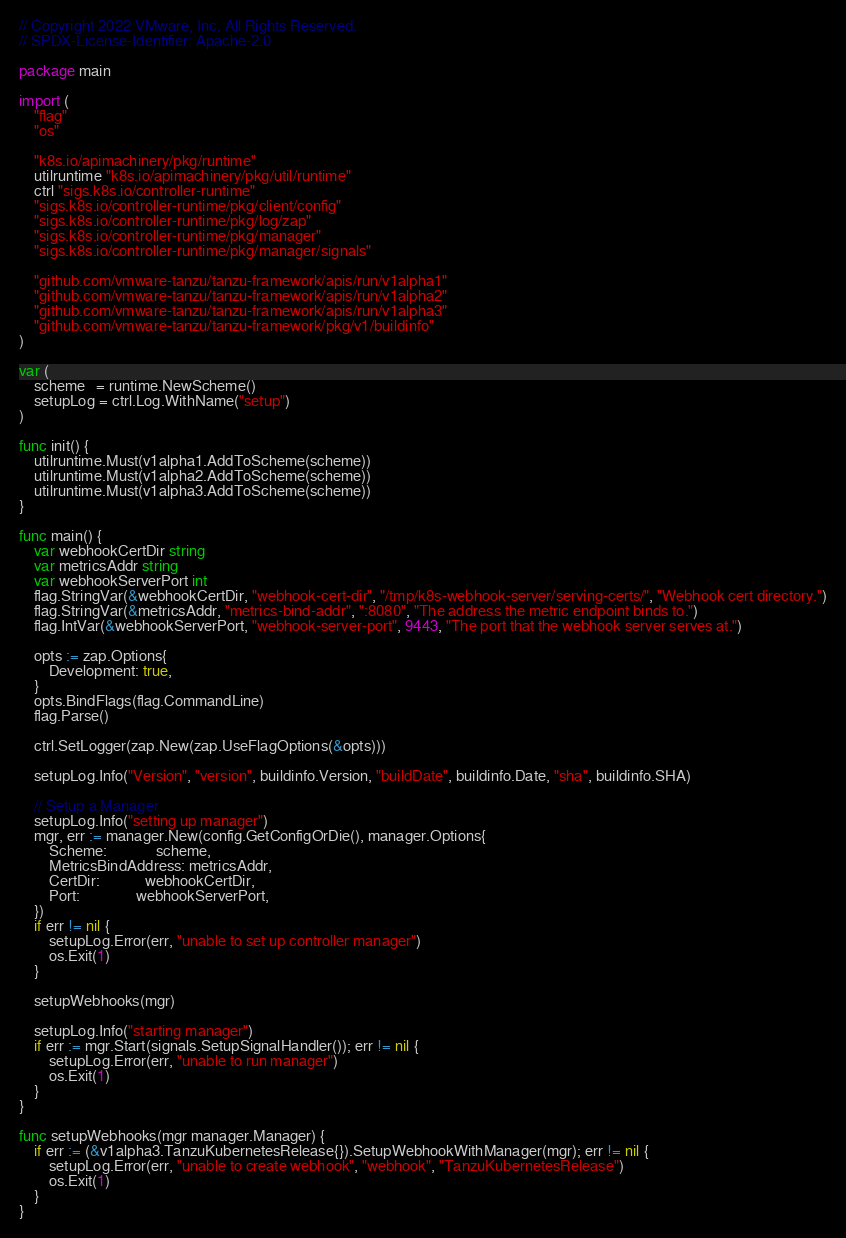Convert code to text. <code><loc_0><loc_0><loc_500><loc_500><_Go_>// Copyright 2022 VMware, Inc. All Rights Reserved.
// SPDX-License-Identifier: Apache-2.0

package main

import (
	"flag"
	"os"

	"k8s.io/apimachinery/pkg/runtime"
	utilruntime "k8s.io/apimachinery/pkg/util/runtime"
	ctrl "sigs.k8s.io/controller-runtime"
	"sigs.k8s.io/controller-runtime/pkg/client/config"
	"sigs.k8s.io/controller-runtime/pkg/log/zap"
	"sigs.k8s.io/controller-runtime/pkg/manager"
	"sigs.k8s.io/controller-runtime/pkg/manager/signals"

	"github.com/vmware-tanzu/tanzu-framework/apis/run/v1alpha1"
	"github.com/vmware-tanzu/tanzu-framework/apis/run/v1alpha2"
	"github.com/vmware-tanzu/tanzu-framework/apis/run/v1alpha3"
	"github.com/vmware-tanzu/tanzu-framework/pkg/v1/buildinfo"
)

var (
	scheme   = runtime.NewScheme()
	setupLog = ctrl.Log.WithName("setup")
)

func init() {
	utilruntime.Must(v1alpha1.AddToScheme(scheme))
	utilruntime.Must(v1alpha2.AddToScheme(scheme))
	utilruntime.Must(v1alpha3.AddToScheme(scheme))
}

func main() {
	var webhookCertDir string
	var metricsAddr string
	var webhookServerPort int
	flag.StringVar(&webhookCertDir, "webhook-cert-dir", "/tmp/k8s-webhook-server/serving-certs/", "Webhook cert directory.")
	flag.StringVar(&metricsAddr, "metrics-bind-addr", ":8080", "The address the metric endpoint binds to.")
	flag.IntVar(&webhookServerPort, "webhook-server-port", 9443, "The port that the webhook server serves at.")

	opts := zap.Options{
		Development: true,
	}
	opts.BindFlags(flag.CommandLine)
	flag.Parse()

	ctrl.SetLogger(zap.New(zap.UseFlagOptions(&opts)))

	setupLog.Info("Version", "version", buildinfo.Version, "buildDate", buildinfo.Date, "sha", buildinfo.SHA)

	// Setup a Manager
	setupLog.Info("setting up manager")
	mgr, err := manager.New(config.GetConfigOrDie(), manager.Options{
		Scheme:             scheme,
		MetricsBindAddress: metricsAddr,
		CertDir:            webhookCertDir,
		Port:               webhookServerPort,
	})
	if err != nil {
		setupLog.Error(err, "unable to set up controller manager")
		os.Exit(1)
	}

	setupWebhooks(mgr)

	setupLog.Info("starting manager")
	if err := mgr.Start(signals.SetupSignalHandler()); err != nil {
		setupLog.Error(err, "unable to run manager")
		os.Exit(1)
	}
}

func setupWebhooks(mgr manager.Manager) {
	if err := (&v1alpha3.TanzuKubernetesRelease{}).SetupWebhookWithManager(mgr); err != nil {
		setupLog.Error(err, "unable to create webhook", "webhook", "TanzuKubernetesRelease")
		os.Exit(1)
	}
}
</code> 